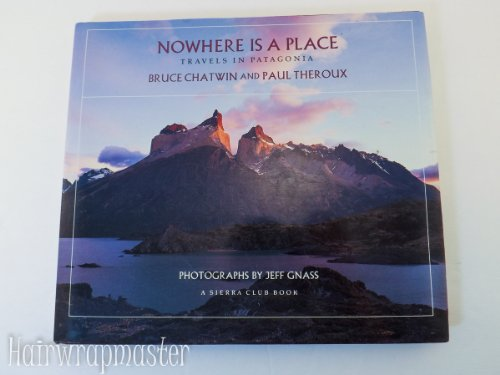What type of book is this? This is a travel book, rich with vivid descriptions and insights into Patagonia's breathtaking landscapes and culture. 